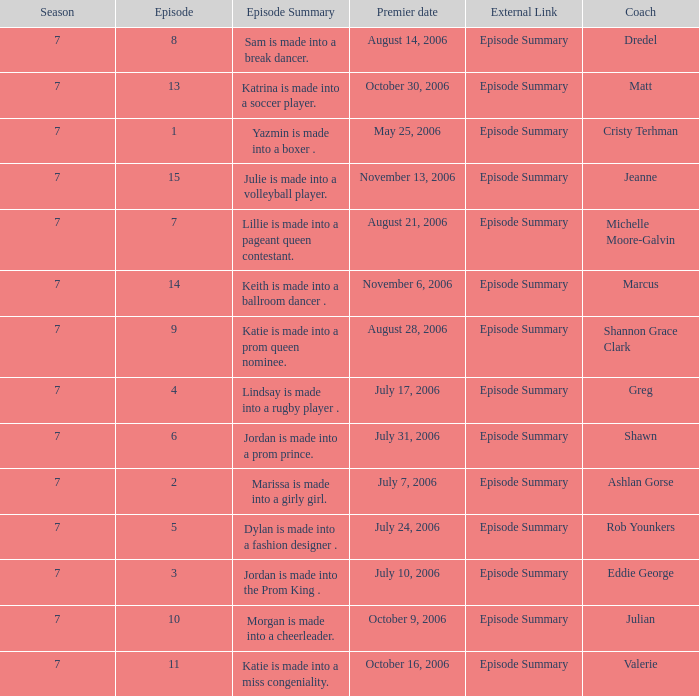How many episodes have Valerie? 1.0. 